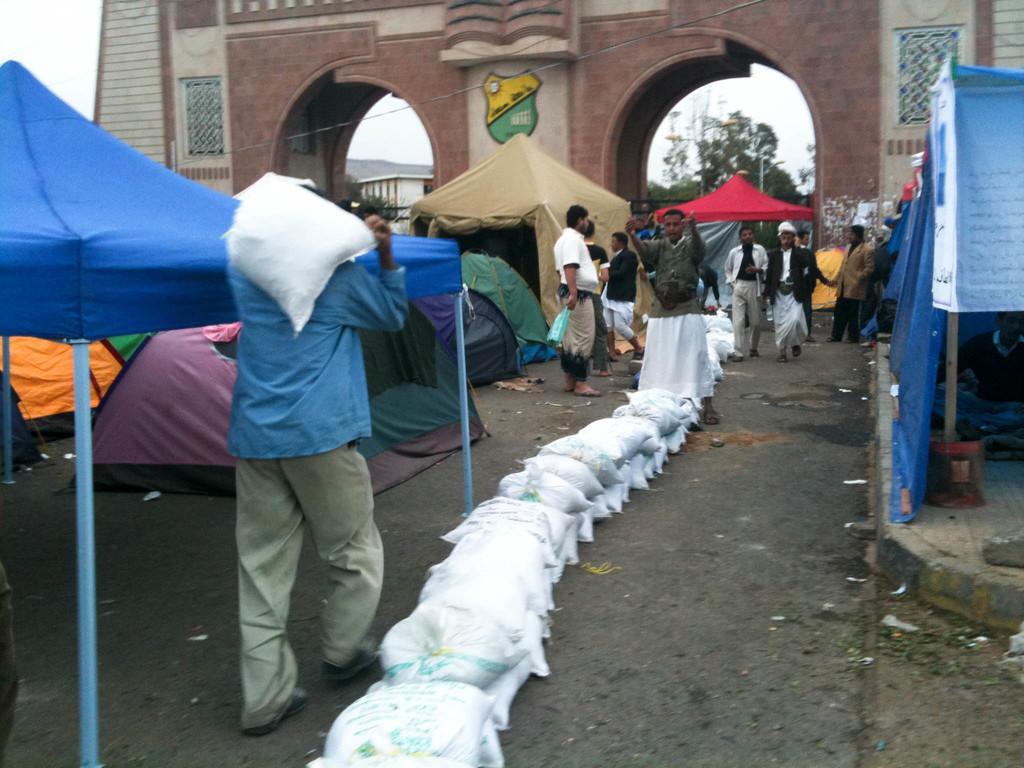In one or two sentences, can you explain what this image depicts? This is an outside view. In the middle of the image I can see few bags on the road. There is a man carrying a bag and walking. In the background, I can see some more people. On the right and left sides of the image I can see two tents. On the right side a person is sitting on the footpath. In the background, I can see some more tents, trees and building. 